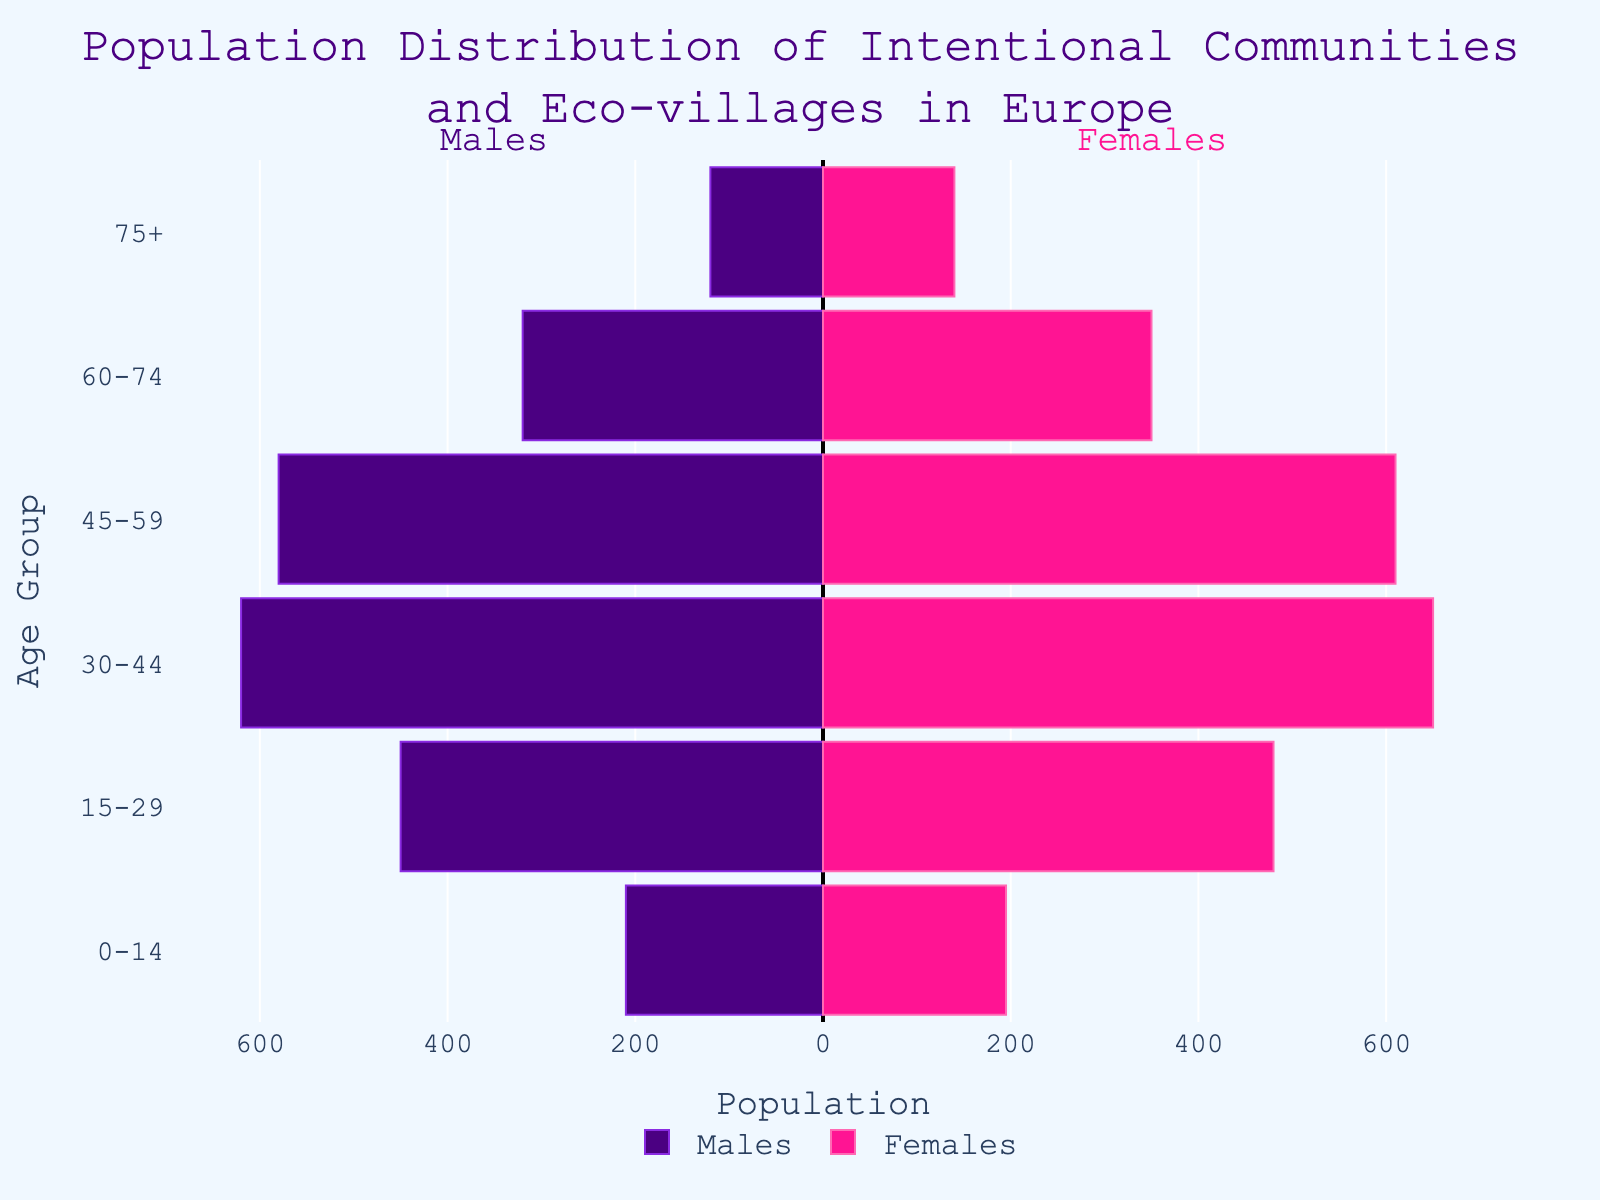What is the title of the figure? The figure's title is placed at the top and reads "Population Distribution of Intentional Communities and Eco-villages in Europe".
Answer: Population Distribution of Intentional Communities and Eco-villages in Europe Which age group has the highest number of males? By looking at the left side of the pyramid (negative bar lengths for males), the age group "30-44" has the longest bar, representing the highest number of males.
Answer: 30-44 What is the total population in the 45-59 age group? The total population is the sum of males and females in the 45-59 age group. According to the figure, there are 580 males and 610 females. Adding them, 580 + 610 = 1190.
Answer: 1190 How does the population of females in the 75+ age group compare to the population of males in the same age group? The bar for females in the 75+ age group is slightly longer than the bar for males. There are 140 females compared to 120 males in this age group.
Answer: Females outnumber males Which is the smallest age group for both males and females? Looking at the shortest bars on both sides of the pyramid, the 0-14 age group has the smallest population for both males (210) and females (195).
Answer: 0-14 What is the difference in population between males and females in the 30-44 age group? The number of females in the 30-44 age group is 650, while males are 620. The difference is 650 - 620 = 30.
Answer: 30 Which age group has the most balanced gender distribution? By observing the lengths of bars for both genders side by side, the 15-29 age group shows a relatively balanced distribution with 450 males and 480 females, a difference of only 30.
Answer: 15-29 How many more females are there than males in the 60-74 age group? The number of females in the 60-74 age group is 350, while the males are 320. The difference is 350 - 320 = 30.
Answer: 30 What is the total population of intentional communities and eco-villages in Europe represented in the figure? To find the total, sum up the populations for both males and females across all age groups. That is, for males, (-210 + -450 + -620 + -580 + -320 + -120) = 2300 and for females, (195 + 480 + 650 + 610 + 350 + 140) = 2425. The total is 2300 + 2425 = 4725.
Answer: 4725 